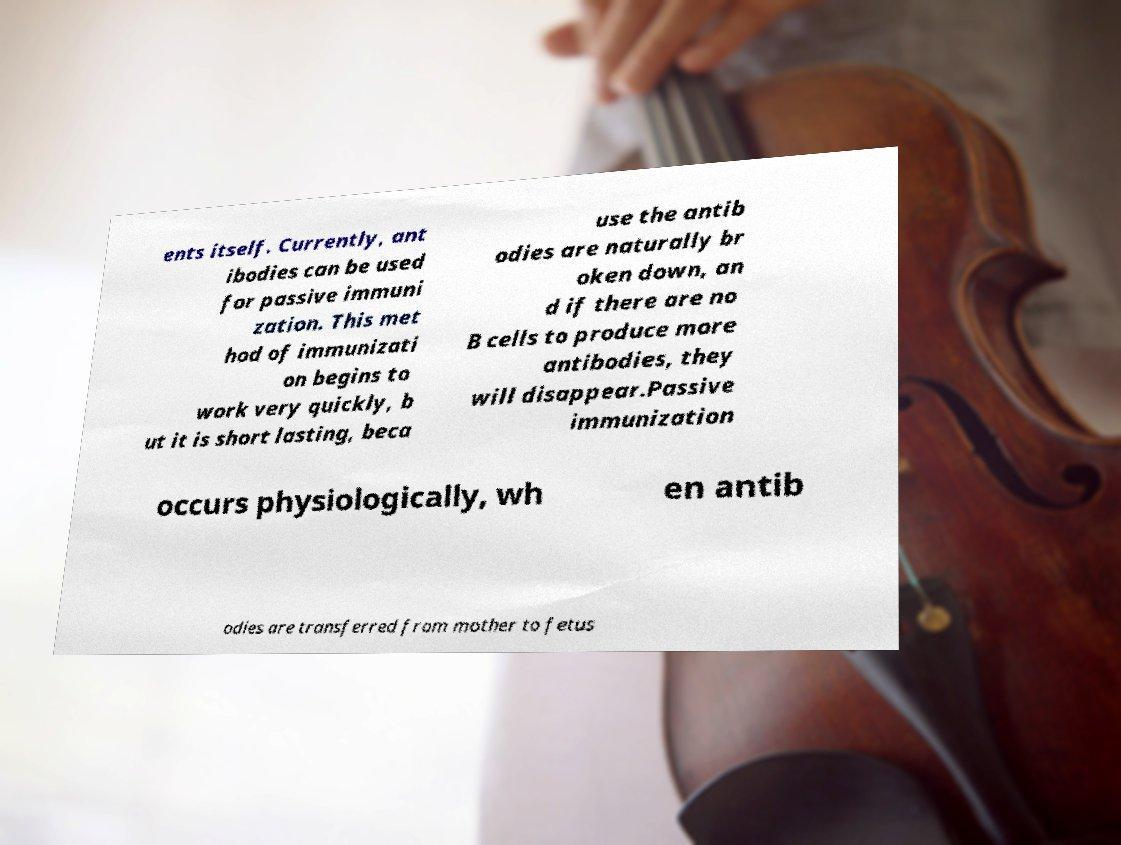What messages or text are displayed in this image? I need them in a readable, typed format. ents itself. Currently, ant ibodies can be used for passive immuni zation. This met hod of immunizati on begins to work very quickly, b ut it is short lasting, beca use the antib odies are naturally br oken down, an d if there are no B cells to produce more antibodies, they will disappear.Passive immunization occurs physiologically, wh en antib odies are transferred from mother to fetus 